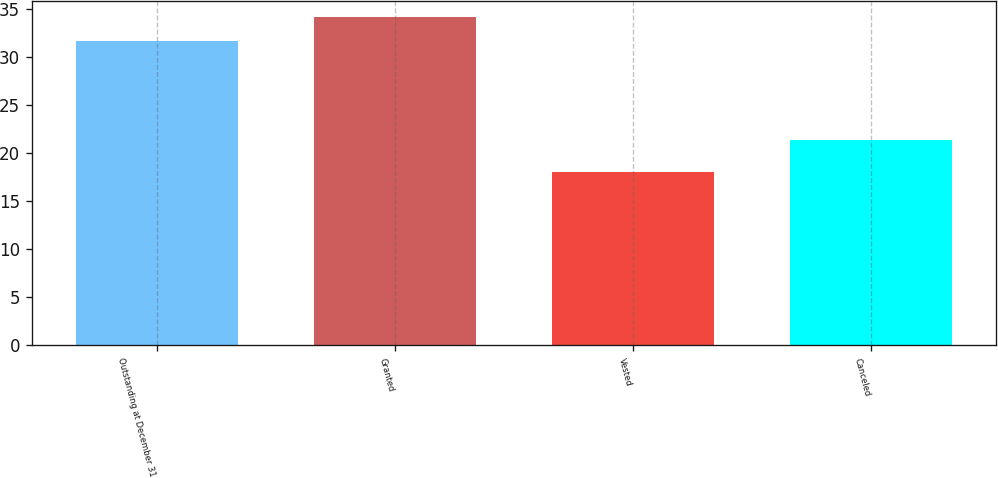Convert chart. <chart><loc_0><loc_0><loc_500><loc_500><bar_chart><fcel>Outstanding at December 31<fcel>Granted<fcel>Vested<fcel>Canceled<nl><fcel>31.65<fcel>34.08<fcel>17.97<fcel>21.37<nl></chart> 